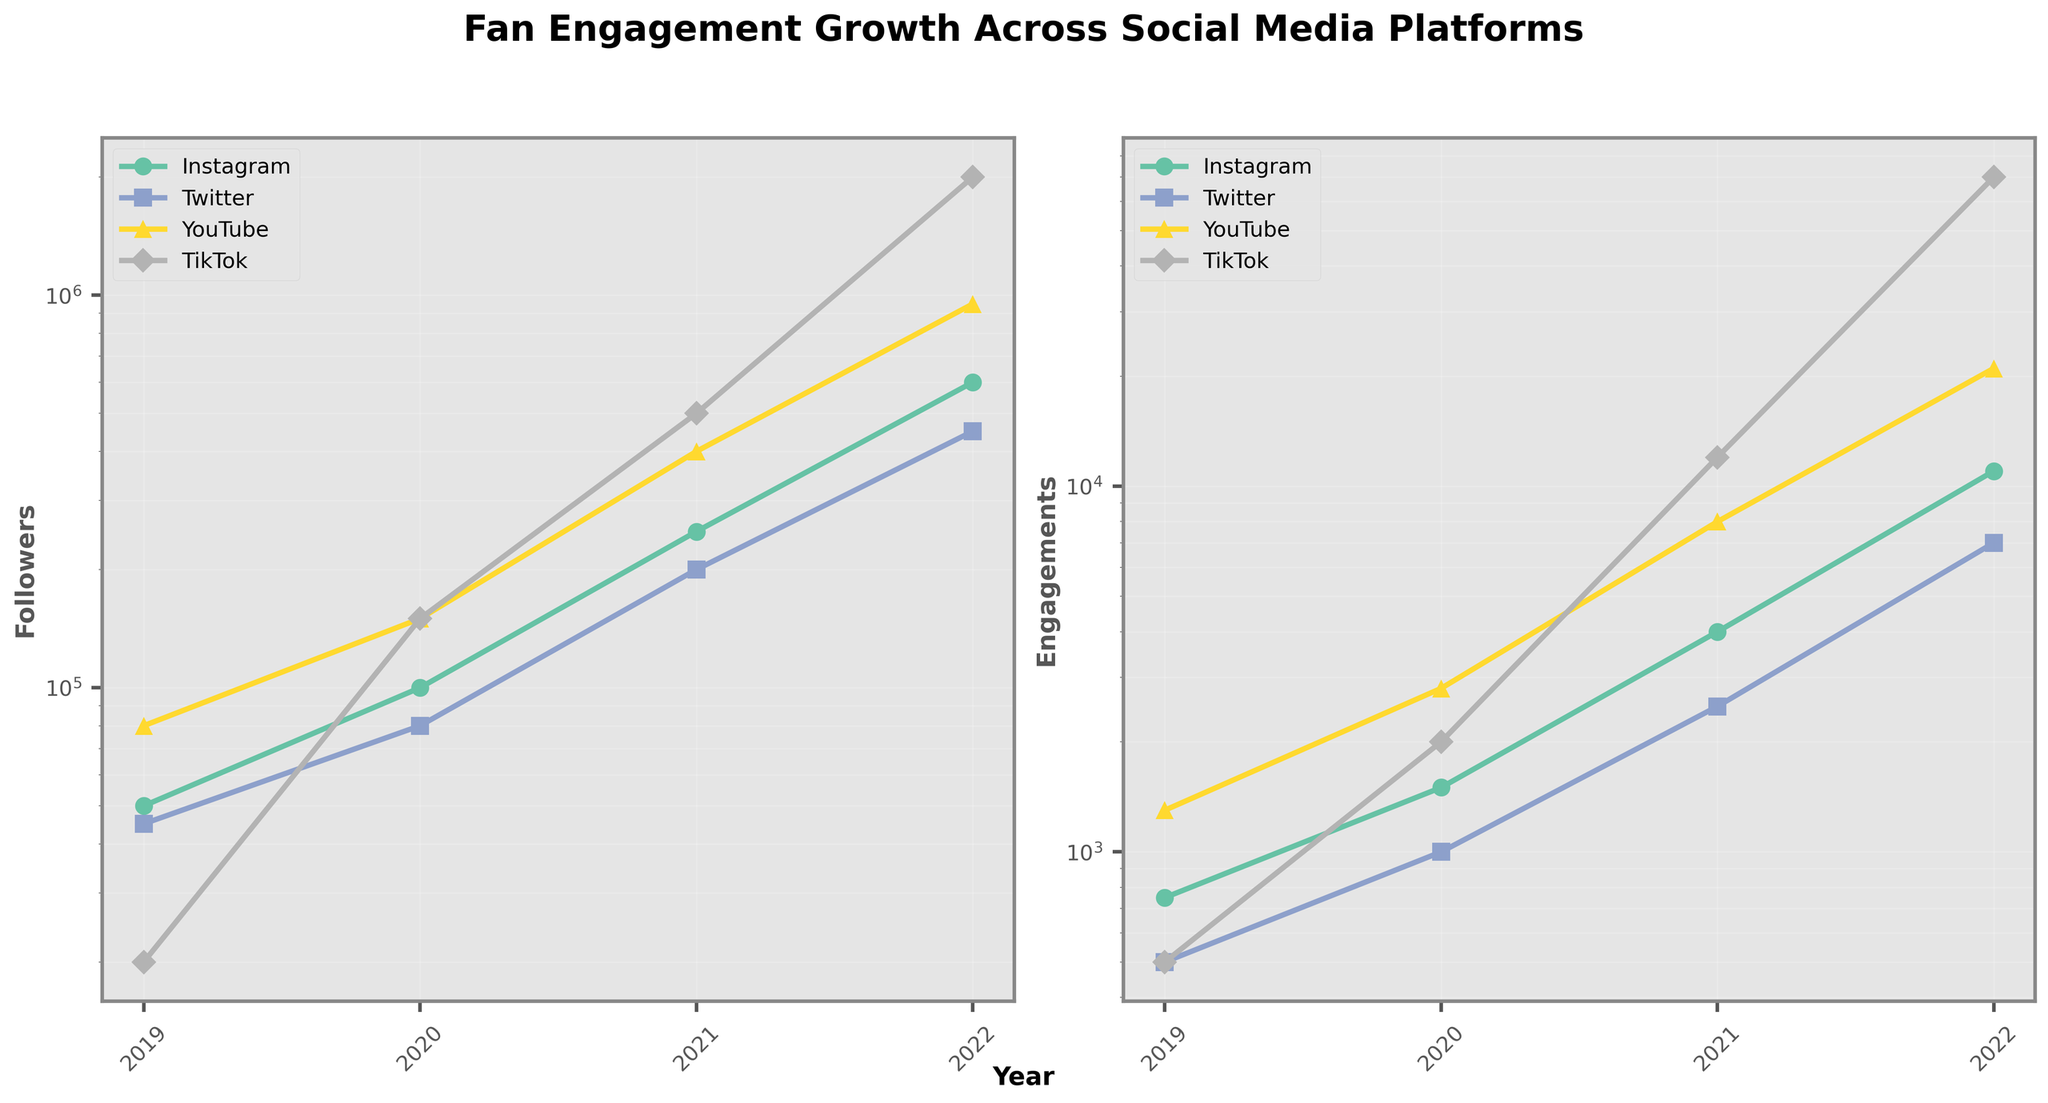How many platforms are represented in the plot? The plot legend shows different colored lines and markers for each platform. By counting these, we find the number of platforms.
Answer: 4 Which platform had the highest number of followers in 2022? On the 'Followers' subplot, identify the line representing 2022 and find the highest data point.
Answer: TikTok Which year saw the largest increase in engagements for YouTube? By examining the 'Engagements' subplot and comparing the year-over-year changes for the YouTube line, you can see the difference between 2021 and 2022 is the largest.
Answer: 2022 Which platform had the lowest engagement in 2020? On the 'Engagements' subplot, identify the data points for 2020 and compare the values across all platforms.
Answer: Twitter How does the follower growth trend of Instagram compare to TikTok over the years? Look at the 'Followers' subplot and compare the slope of the Instagram line to the TikTok line over the years. TikTok's line is steeper, indicating faster growth.
Answer: TikTok has faster growth By what factor did TikTok's engagements increase from 2019 to 2022? Calculate the ratio of engagements in 2022 to 2019 for TikTok from the 'Engagements' subplot: 70000 / 500 = 140.
Answer: 140 Which platform shows a more consistent year-over-year growth in both followers and engagements? Examine both subplots and look for the platform with smooth, steadily increasing lines in both plots. Instagram's lines are smoother compared to others.
Answer: Instagram What is the average number of followers for YouTube in the years 2019-2022? Sum the followers for YouTube over these years and divide by 4: (80000 + 150000 + 400000 + 950000) / 4 = 395000.
Answer: 395000 If you combine the engagements of Instagram and Twitter in 2020, what is the total? Add the 2020 engagements for Instagram and Twitter from the subplot: 1500 (Instagram) + 1000 (Twitter) = 2500.
Answer: 2500 Which platform had the largest percentage increase in followers from 2019 to 2022? Calculate the percentage increase for each platform by using (2022 followers - 2019 followers) / 2019 followers * 100 and compare the results. TikTok has the highest percentage increase.
Answer: TikTok 